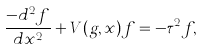Convert formula to latex. <formula><loc_0><loc_0><loc_500><loc_500>\frac { - d ^ { 2 } f } { d x ^ { 2 } } + V ( g , x ) f = - \tau ^ { 2 } f ,</formula> 